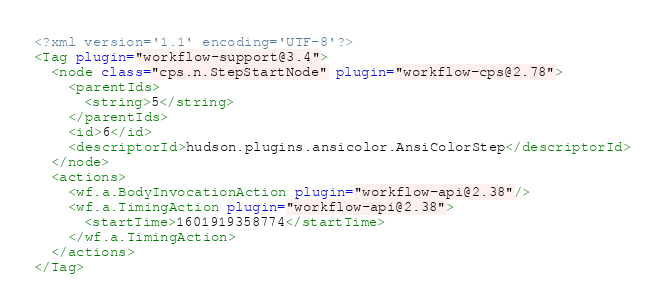<code> <loc_0><loc_0><loc_500><loc_500><_XML_><?xml version='1.1' encoding='UTF-8'?>
<Tag plugin="workflow-support@3.4">
  <node class="cps.n.StepStartNode" plugin="workflow-cps@2.78">
    <parentIds>
      <string>5</string>
    </parentIds>
    <id>6</id>
    <descriptorId>hudson.plugins.ansicolor.AnsiColorStep</descriptorId>
  </node>
  <actions>
    <wf.a.BodyInvocationAction plugin="workflow-api@2.38"/>
    <wf.a.TimingAction plugin="workflow-api@2.38">
      <startTime>1601919358774</startTime>
    </wf.a.TimingAction>
  </actions>
</Tag></code> 